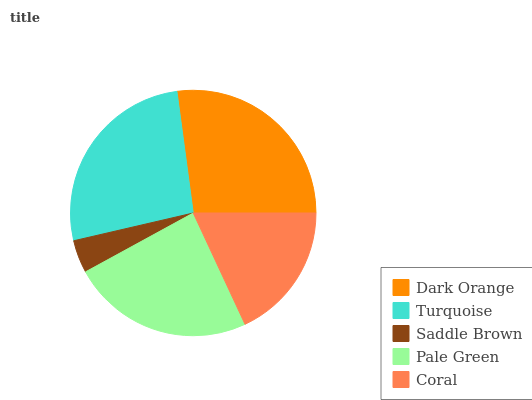Is Saddle Brown the minimum?
Answer yes or no. Yes. Is Dark Orange the maximum?
Answer yes or no. Yes. Is Turquoise the minimum?
Answer yes or no. No. Is Turquoise the maximum?
Answer yes or no. No. Is Dark Orange greater than Turquoise?
Answer yes or no. Yes. Is Turquoise less than Dark Orange?
Answer yes or no. Yes. Is Turquoise greater than Dark Orange?
Answer yes or no. No. Is Dark Orange less than Turquoise?
Answer yes or no. No. Is Pale Green the high median?
Answer yes or no. Yes. Is Pale Green the low median?
Answer yes or no. Yes. Is Dark Orange the high median?
Answer yes or no. No. Is Dark Orange the low median?
Answer yes or no. No. 